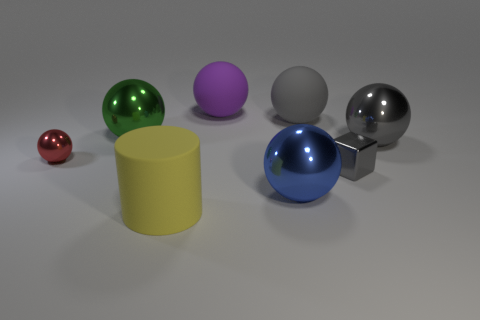Subtract 1 spheres. How many spheres are left? 5 Subtract all blue balls. How many balls are left? 5 Subtract all red balls. How many balls are left? 5 Subtract all brown cylinders. Subtract all yellow spheres. How many cylinders are left? 1 Add 2 tiny cyan metallic balls. How many objects exist? 10 Subtract all cubes. How many objects are left? 7 Add 4 large blue objects. How many large blue objects are left? 5 Add 1 large green metallic objects. How many large green metallic objects exist? 2 Subtract 0 brown cylinders. How many objects are left? 8 Subtract all brown shiny cubes. Subtract all blue balls. How many objects are left? 7 